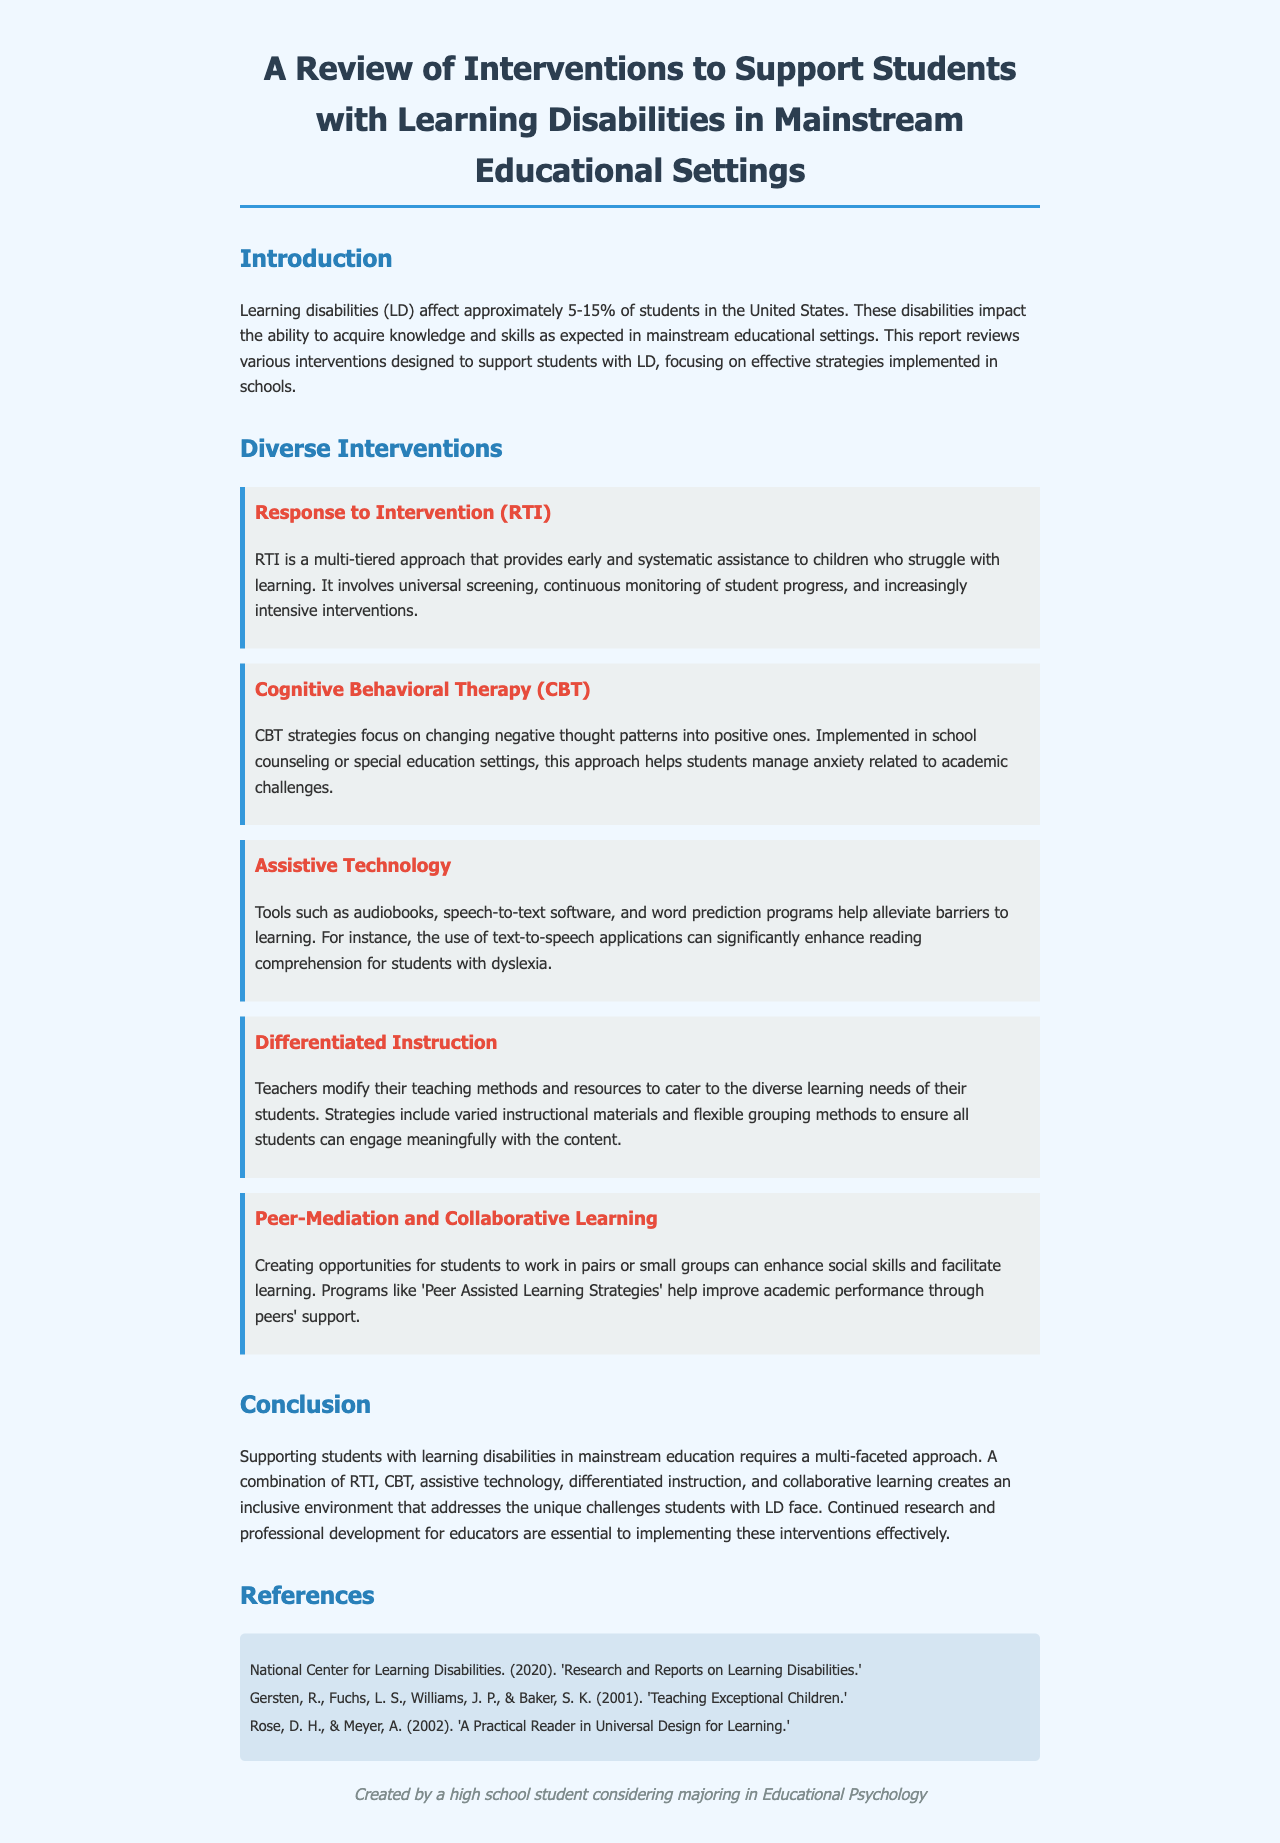what is the percentage of students with learning disabilities in the United States? The document states that learning disabilities affect approximately 5-15% of students in the United States.
Answer: 5-15% what is the title of the first intervention discussed? The first intervention mentioned in the document is RTI, which stands for Response to Intervention.
Answer: Response to Intervention what type of therapy is mentioned as an intervention focusing on anxiety? The report discusses Cognitive Behavioral Therapy (CBT) as an intervention that addresses anxiety.
Answer: Cognitive Behavioral Therapy which assistive technology tool is specifically mentioned to enhance reading comprehension? The document mentions text-to-speech applications as tools that can significantly enhance reading comprehension for students with dyslexia.
Answer: text-to-speech applications what instructional approach involves modifying teaching methods to meet diverse needs? The document describes Differentiated Instruction as the approach that modifies teaching methods to cater to diverse learning needs.
Answer: Differentiated Instruction what collaborative strategy is mentioned in the report? The report mentions Peer Assisted Learning Strategies as a collaborative strategy to improve academic performance.
Answer: Peer Assisted Learning Strategies what is crucial for effectively implementing the discussed interventions? The document emphasizes that continued research and professional development for educators is essential for implementing interventions effectively.
Answer: professional development for educators 